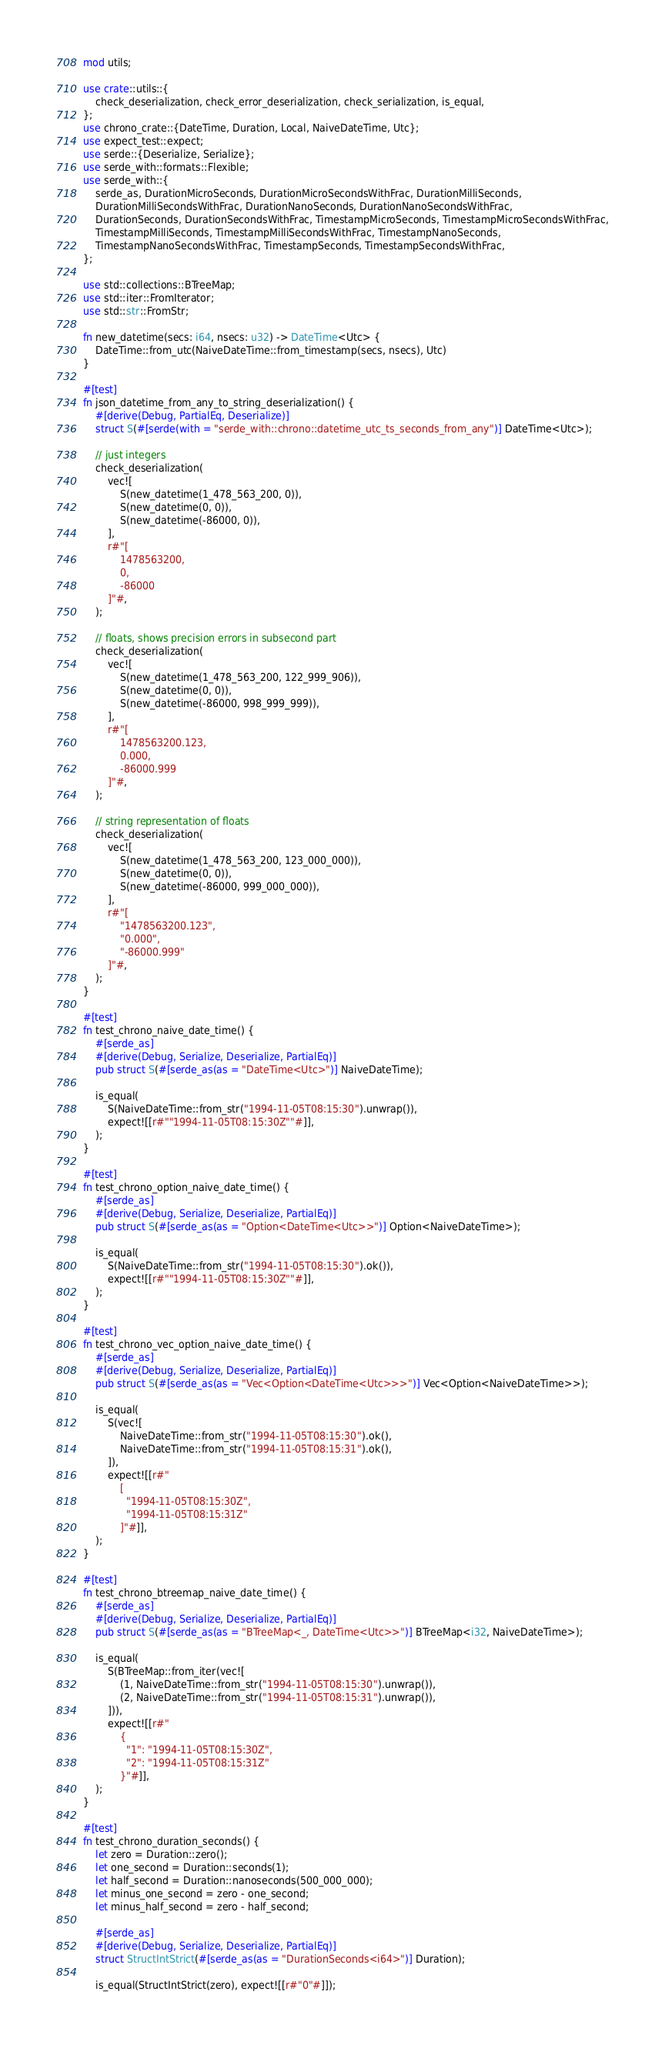<code> <loc_0><loc_0><loc_500><loc_500><_Rust_>mod utils;

use crate::utils::{
    check_deserialization, check_error_deserialization, check_serialization, is_equal,
};
use chrono_crate::{DateTime, Duration, Local, NaiveDateTime, Utc};
use expect_test::expect;
use serde::{Deserialize, Serialize};
use serde_with::formats::Flexible;
use serde_with::{
    serde_as, DurationMicroSeconds, DurationMicroSecondsWithFrac, DurationMilliSeconds,
    DurationMilliSecondsWithFrac, DurationNanoSeconds, DurationNanoSecondsWithFrac,
    DurationSeconds, DurationSecondsWithFrac, TimestampMicroSeconds, TimestampMicroSecondsWithFrac,
    TimestampMilliSeconds, TimestampMilliSecondsWithFrac, TimestampNanoSeconds,
    TimestampNanoSecondsWithFrac, TimestampSeconds, TimestampSecondsWithFrac,
};

use std::collections::BTreeMap;
use std::iter::FromIterator;
use std::str::FromStr;

fn new_datetime(secs: i64, nsecs: u32) -> DateTime<Utc> {
    DateTime::from_utc(NaiveDateTime::from_timestamp(secs, nsecs), Utc)
}

#[test]
fn json_datetime_from_any_to_string_deserialization() {
    #[derive(Debug, PartialEq, Deserialize)]
    struct S(#[serde(with = "serde_with::chrono::datetime_utc_ts_seconds_from_any")] DateTime<Utc>);

    // just integers
    check_deserialization(
        vec![
            S(new_datetime(1_478_563_200, 0)),
            S(new_datetime(0, 0)),
            S(new_datetime(-86000, 0)),
        ],
        r#"[
            1478563200,
            0,
            -86000
        ]"#,
    );

    // floats, shows precision errors in subsecond part
    check_deserialization(
        vec![
            S(new_datetime(1_478_563_200, 122_999_906)),
            S(new_datetime(0, 0)),
            S(new_datetime(-86000, 998_999_999)),
        ],
        r#"[
            1478563200.123,
            0.000,
            -86000.999
        ]"#,
    );

    // string representation of floats
    check_deserialization(
        vec![
            S(new_datetime(1_478_563_200, 123_000_000)),
            S(new_datetime(0, 0)),
            S(new_datetime(-86000, 999_000_000)),
        ],
        r#"[
            "1478563200.123",
            "0.000",
            "-86000.999"
        ]"#,
    );
}

#[test]
fn test_chrono_naive_date_time() {
    #[serde_as]
    #[derive(Debug, Serialize, Deserialize, PartialEq)]
    pub struct S(#[serde_as(as = "DateTime<Utc>")] NaiveDateTime);

    is_equal(
        S(NaiveDateTime::from_str("1994-11-05T08:15:30").unwrap()),
        expect![[r#""1994-11-05T08:15:30Z""#]],
    );
}

#[test]
fn test_chrono_option_naive_date_time() {
    #[serde_as]
    #[derive(Debug, Serialize, Deserialize, PartialEq)]
    pub struct S(#[serde_as(as = "Option<DateTime<Utc>>")] Option<NaiveDateTime>);

    is_equal(
        S(NaiveDateTime::from_str("1994-11-05T08:15:30").ok()),
        expect![[r#""1994-11-05T08:15:30Z""#]],
    );
}

#[test]
fn test_chrono_vec_option_naive_date_time() {
    #[serde_as]
    #[derive(Debug, Serialize, Deserialize, PartialEq)]
    pub struct S(#[serde_as(as = "Vec<Option<DateTime<Utc>>>")] Vec<Option<NaiveDateTime>>);

    is_equal(
        S(vec![
            NaiveDateTime::from_str("1994-11-05T08:15:30").ok(),
            NaiveDateTime::from_str("1994-11-05T08:15:31").ok(),
        ]),
        expect![[r#"
            [
              "1994-11-05T08:15:30Z",
              "1994-11-05T08:15:31Z"
            ]"#]],
    );
}

#[test]
fn test_chrono_btreemap_naive_date_time() {
    #[serde_as]
    #[derive(Debug, Serialize, Deserialize, PartialEq)]
    pub struct S(#[serde_as(as = "BTreeMap<_, DateTime<Utc>>")] BTreeMap<i32, NaiveDateTime>);

    is_equal(
        S(BTreeMap::from_iter(vec![
            (1, NaiveDateTime::from_str("1994-11-05T08:15:30").unwrap()),
            (2, NaiveDateTime::from_str("1994-11-05T08:15:31").unwrap()),
        ])),
        expect![[r#"
            {
              "1": "1994-11-05T08:15:30Z",
              "2": "1994-11-05T08:15:31Z"
            }"#]],
    );
}

#[test]
fn test_chrono_duration_seconds() {
    let zero = Duration::zero();
    let one_second = Duration::seconds(1);
    let half_second = Duration::nanoseconds(500_000_000);
    let minus_one_second = zero - one_second;
    let minus_half_second = zero - half_second;

    #[serde_as]
    #[derive(Debug, Serialize, Deserialize, PartialEq)]
    struct StructIntStrict(#[serde_as(as = "DurationSeconds<i64>")] Duration);

    is_equal(StructIntStrict(zero), expect![[r#"0"#]]);</code> 